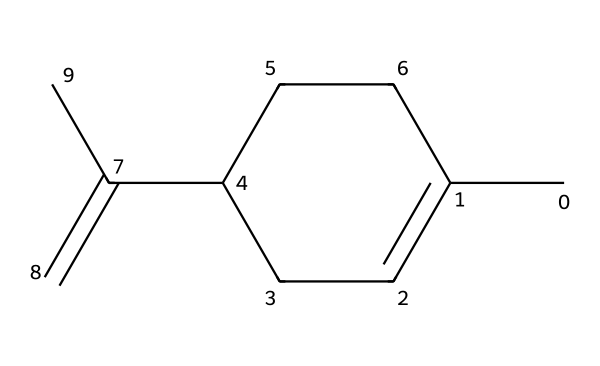What is the chemical name of this compound? The provided SMILES corresponds to limonene, which is a common terpene found in citrus fruits, recognizable by its specific structure, including the cyclohexene ring and the presence of a double bond.
Answer: limonene How many carbon atoms are in this molecule? By examining the SMILES representation, we can count the carbon atoms annotated within, totaling 10 carbon atoms present in the structure.
Answer: 10 How many double bonds are present in limonene? The SMILES shows one C=C double bond in the structure, indicating that there is one double bond present in limonene.
Answer: 1 What functional group is indicated by the double bond in this structure? The double bond in limonene represents an alkene functional group, which characterizes this compound as a hydrocarbon with unsaturation.
Answer: alkene What type of compound is limonene classified as? Limonene is a specific type of chemical known as a terpene, which is a category of organic compounds derived from plants, especially those with aromatic qualities.
Answer: terpene In what types of products is limonene commonly found? Limonene is frequently found in essential oils, cosmetics, and cleaning products, reflecting its use in natural fragrances and oils as a key ingredient.
Answer: essential oils How does the structure of limonene contribute to its aroma? The arrangement of the carbon chains, cycloalkanes, and the presence of the double bond contribute to limonene’s pleasant citrus fragrance, appealing in culinary and fragrant applications.
Answer: pleasant citrus fragrance 